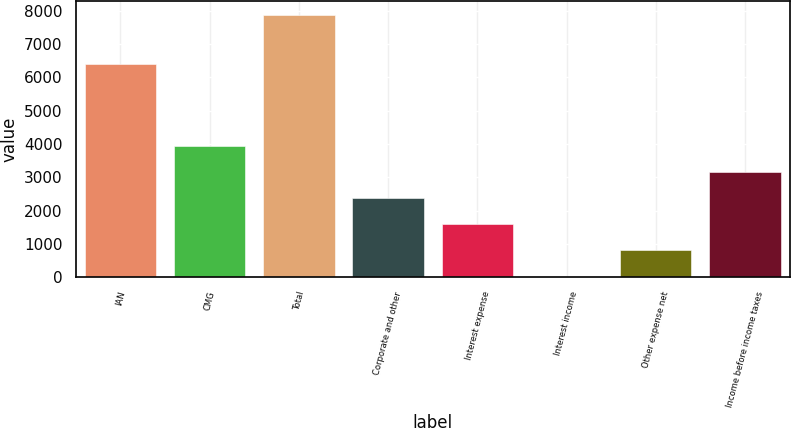Convert chart to OTSL. <chart><loc_0><loc_0><loc_500><loc_500><bar_chart><fcel>IAN<fcel>CMG<fcel>Total<fcel>Corporate and other<fcel>Interest expense<fcel>Interest income<fcel>Other expense net<fcel>Income before income taxes<nl><fcel>6397.3<fcel>3950.9<fcel>7882.4<fcel>2378.3<fcel>1592<fcel>19.4<fcel>805.7<fcel>3164.6<nl></chart> 